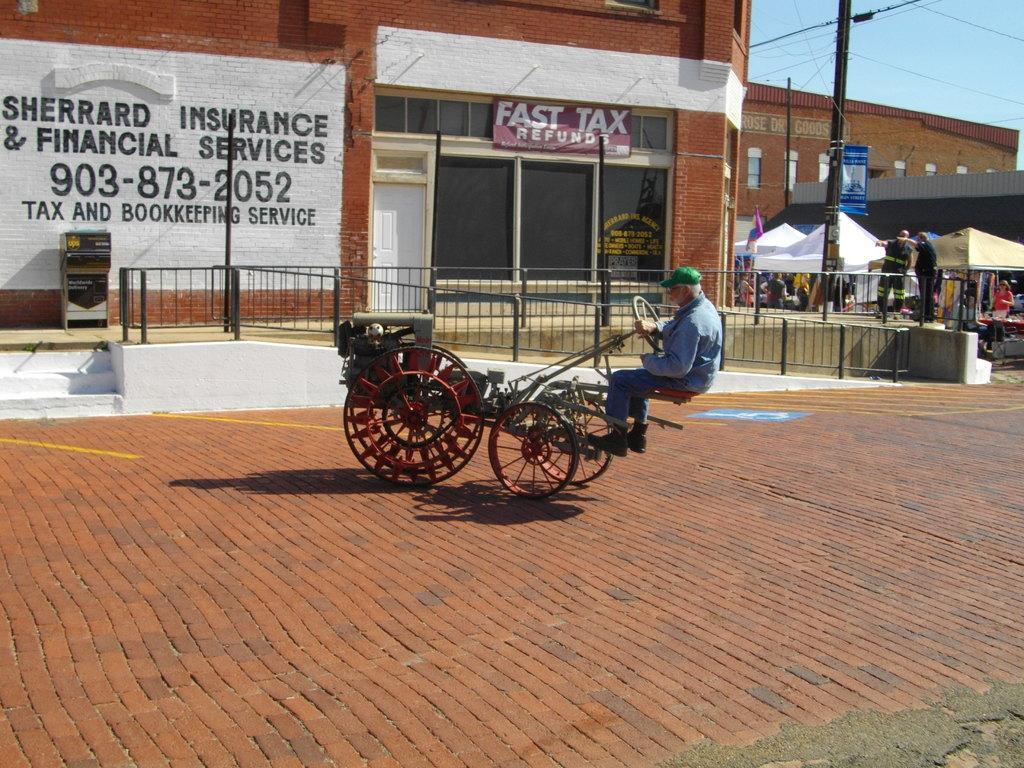Can you describe this image briefly? In the center of the image, we can see a person sitting on the cart and in the background, there are buildings, poles, boards, stands and we can see railings, banners and a flag and some other people and there are wires. At the bottom, there is road and at the top, there is sky. 